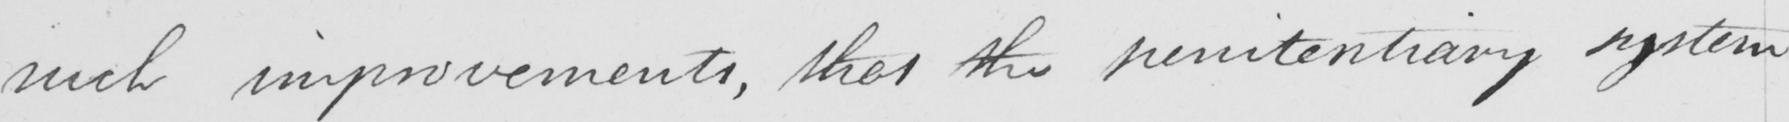What does this handwritten line say? such improvements , that the penitentiary system 